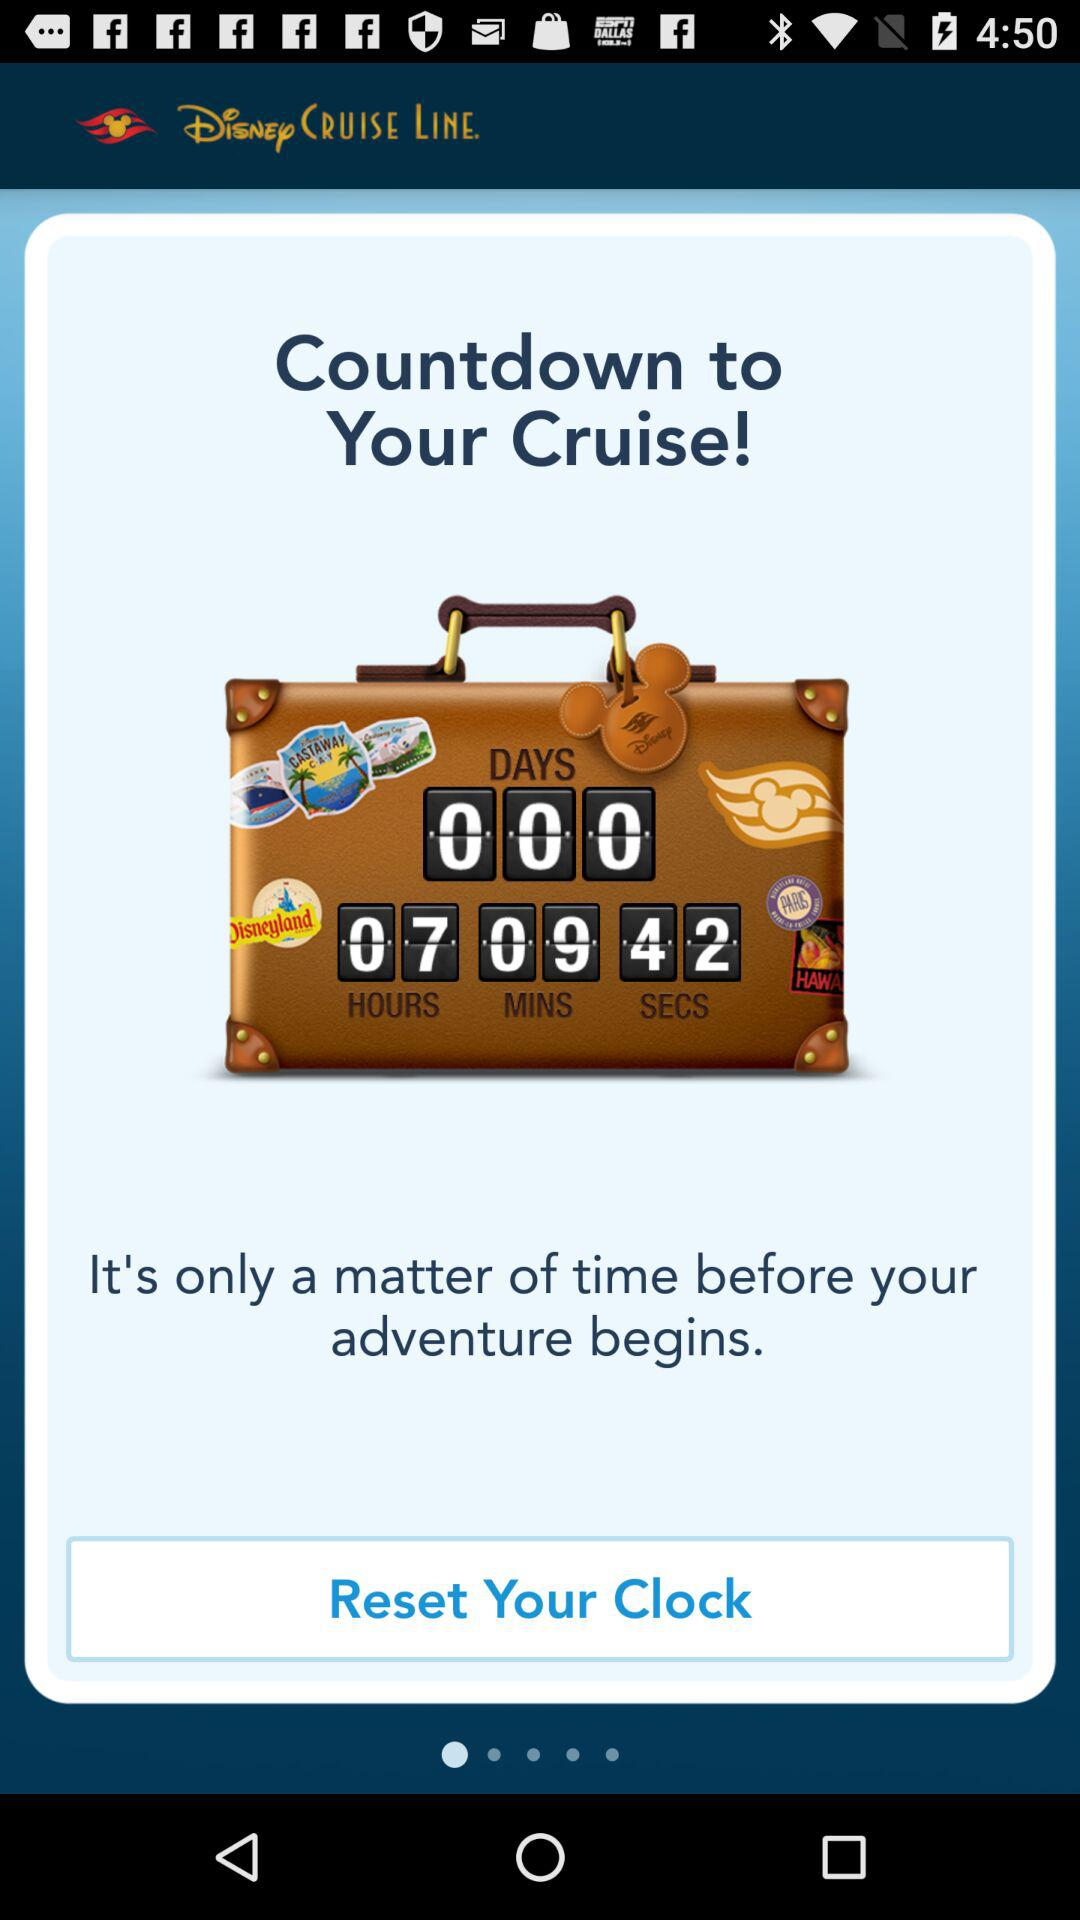How many hours are left for the countdown to your cruise? There are 7 hours left. 